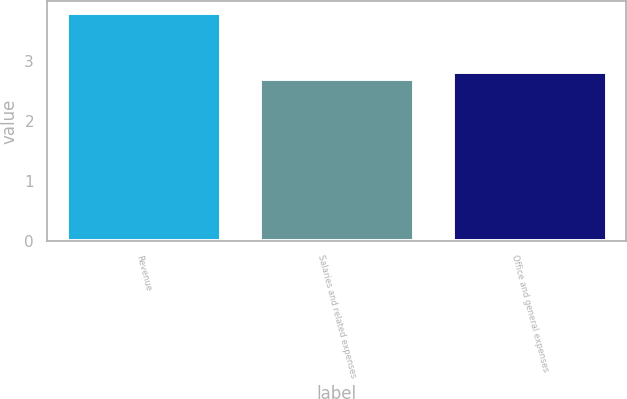<chart> <loc_0><loc_0><loc_500><loc_500><bar_chart><fcel>Revenue<fcel>Salaries and related expenses<fcel>Office and general expenses<nl><fcel>3.8<fcel>2.7<fcel>2.81<nl></chart> 